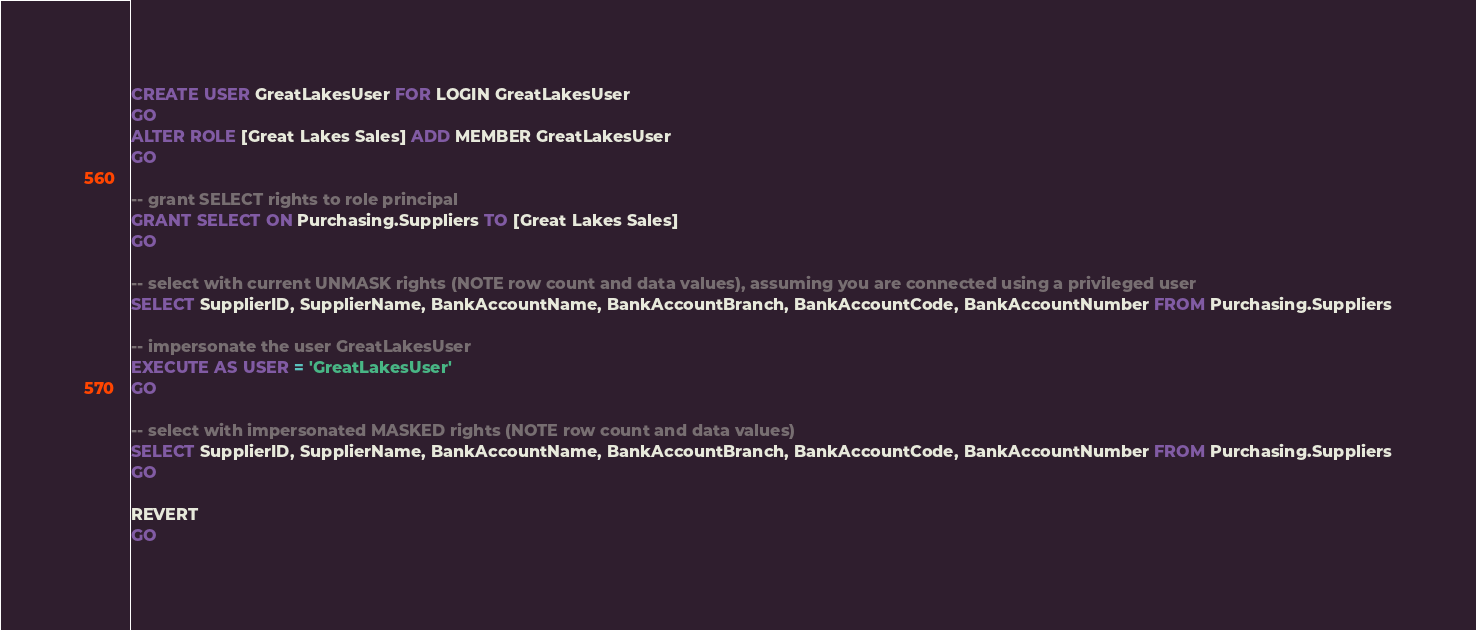<code> <loc_0><loc_0><loc_500><loc_500><_SQL_>CREATE USER GreatLakesUser FOR LOGIN GreatLakesUser
GO
ALTER ROLE [Great Lakes Sales] ADD MEMBER GreatLakesUser
GO

-- grant SELECT rights to role principal
GRANT SELECT ON Purchasing.Suppliers TO [Great Lakes Sales]
GO

-- select with current UNMASK rights (NOTE row count and data values), assuming you are connected using a privileged user
SELECT SupplierID, SupplierName, BankAccountName, BankAccountBranch, BankAccountCode, BankAccountNumber FROM Purchasing.Suppliers

-- impersonate the user GreatLakesUser
EXECUTE AS USER = 'GreatLakesUser'
GO

-- select with impersonated MASKED rights (NOTE row count and data values)
SELECT SupplierID, SupplierName, BankAccountName, BankAccountBranch, BankAccountCode, BankAccountNumber FROM Purchasing.Suppliers
GO

REVERT
GO</code> 